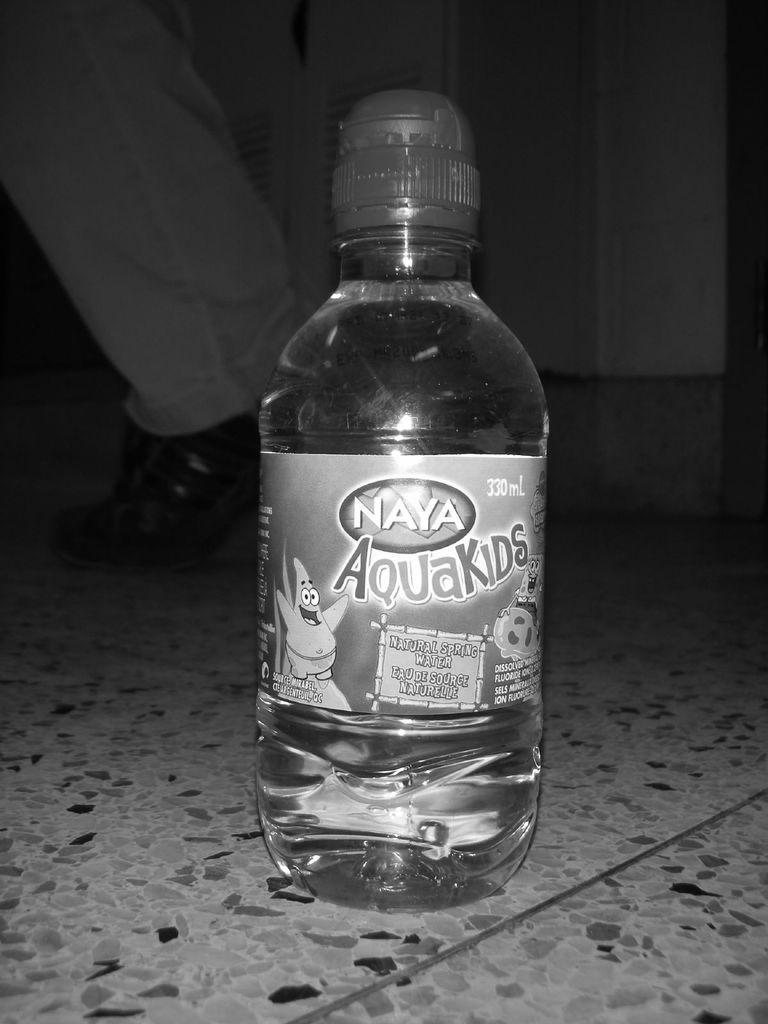Can you describe this image briefly? This is a black and white image of a bottle on a floor. On the bottle there is a label. In the back we can see a leg of a person. 